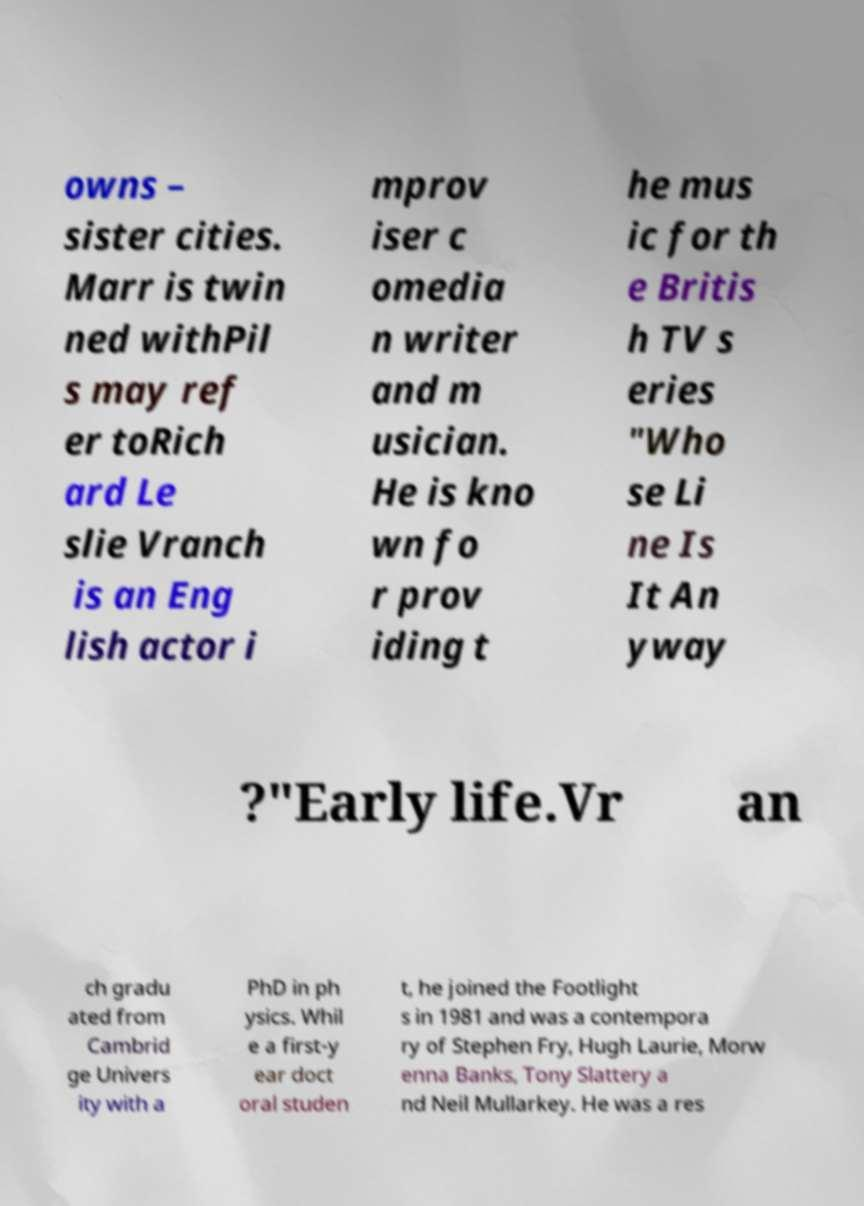Could you extract and type out the text from this image? owns – sister cities. Marr is twin ned withPil s may ref er toRich ard Le slie Vranch is an Eng lish actor i mprov iser c omedia n writer and m usician. He is kno wn fo r prov iding t he mus ic for th e Britis h TV s eries "Who se Li ne Is It An yway ?"Early life.Vr an ch gradu ated from Cambrid ge Univers ity with a PhD in ph ysics. Whil e a first-y ear doct oral studen t, he joined the Footlight s in 1981 and was a contempora ry of Stephen Fry, Hugh Laurie, Morw enna Banks, Tony Slattery a nd Neil Mullarkey. He was a res 